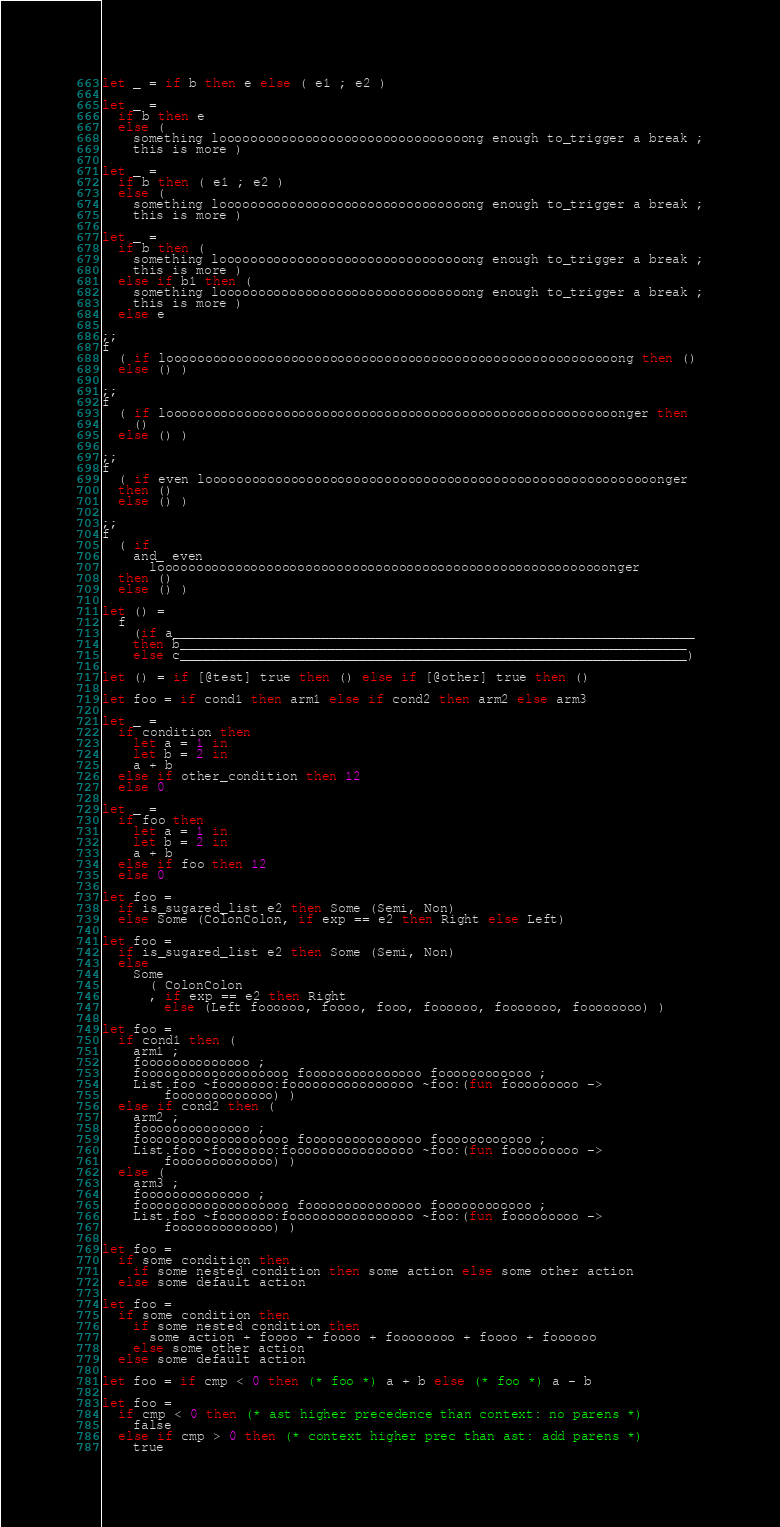Convert code to text. <code><loc_0><loc_0><loc_500><loc_500><_OCaml_>let _ = if b then e else ( e1 ; e2 )

let _ =
  if b then e
  else (
    something loooooooooooooooooooooooooooooooong enough to_trigger a break ;
    this is more )

let _ =
  if b then ( e1 ; e2 )
  else (
    something loooooooooooooooooooooooooooooooong enough to_trigger a break ;
    this is more )

let _ =
  if b then (
    something loooooooooooooooooooooooooooooooong enough to_trigger a break ;
    this is more )
  else if b1 then (
    something loooooooooooooooooooooooooooooooong enough to_trigger a break ;
    this is more )
  else e

;;
f
  ( if loooooooooooooooooooooooooooooooooooooooooooooooooooooooooong then ()
  else () )

;;
f
  ( if loooooooooooooooooooooooooooooooooooooooooooooooooooooooooonger then
    ()
  else () )

;;
f
  ( if even loooooooooooooooooooooooooooooooooooooooooooooooooooooooooonger
  then ()
  else () )

;;
f
  ( if
    and_ even
      loooooooooooooooooooooooooooooooooooooooooooooooooooooooooonger
  then ()
  else () )

let () =
  f
    (if a___________________________________________________________________
    then b_________________________________________________________________
    else c_________________________________________________________________)

let () = if [@test] true then () else if [@other] true then ()

let foo = if cond1 then arm1 else if cond2 then arm2 else arm3

let _ =
  if condition then
    let a = 1 in
    let b = 2 in
    a + b
  else if other_condition then 12
  else 0

let _ =
  if foo then
    let a = 1 in
    let b = 2 in
    a + b
  else if foo then 12
  else 0

let foo =
  if is_sugared_list e2 then Some (Semi, Non)
  else Some (ColonColon, if exp == e2 then Right else Left)

let foo =
  if is_sugared_list e2 then Some (Semi, Non)
  else
    Some
      ( ColonColon
      , if exp == e2 then Right
        else (Left foooooo, foooo, fooo, foooooo, fooooooo, foooooooo) )

let foo =
  if cond1 then (
    arm1 ;
    foooooooooooooo ;
    fooooooooooooooooooo fooooooooooooooo foooooooooooo ;
    List.foo ~fooooooo:foooooooooooooooo ~foo:(fun fooooooooo ->
        fooooooooooooo) )
  else if cond2 then (
    arm2 ;
    foooooooooooooo ;
    fooooooooooooooooooo fooooooooooooooo foooooooooooo ;
    List.foo ~fooooooo:foooooooooooooooo ~foo:(fun fooooooooo ->
        fooooooooooooo) )
  else (
    arm3 ;
    foooooooooooooo ;
    fooooooooooooooooooo fooooooooooooooo foooooooooooo ;
    List.foo ~fooooooo:foooooooooooooooo ~foo:(fun fooooooooo ->
        fooooooooooooo) )

let foo =
  if some condition then
    if some nested condition then some action else some other action
  else some default action

let foo =
  if some condition then
    if some nested condition then
      some action + foooo + foooo + foooooooo + foooo + foooooo
    else some other action
  else some default action

let foo = if cmp < 0 then (* foo *) a + b else (* foo *) a - b

let foo =
  if cmp < 0 then (* ast higher precedence than context: no parens *)
    false
  else if cmp > 0 then (* context higher prec than ast: add parens *)
    true</code> 